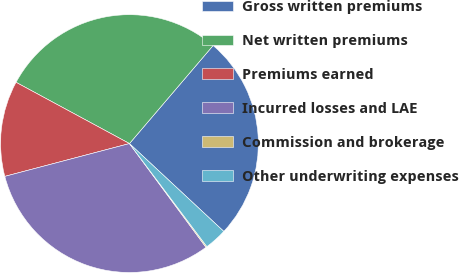Convert chart to OTSL. <chart><loc_0><loc_0><loc_500><loc_500><pie_chart><fcel>Gross written premiums<fcel>Net written premiums<fcel>Premiums earned<fcel>Incurred losses and LAE<fcel>Commission and brokerage<fcel>Other underwriting expenses<nl><fcel>25.69%<fcel>28.36%<fcel>11.98%<fcel>31.02%<fcel>0.14%<fcel>2.81%<nl></chart> 